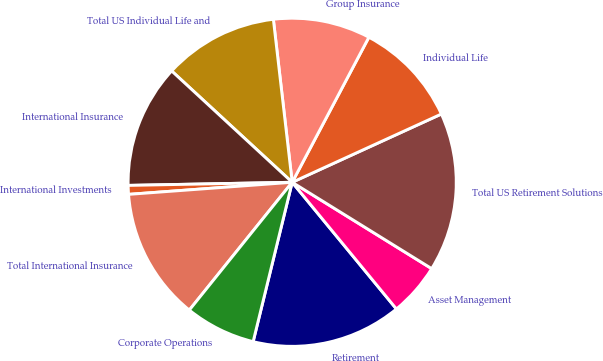<chart> <loc_0><loc_0><loc_500><loc_500><pie_chart><fcel>Retirement<fcel>Asset Management<fcel>Total US Retirement Solutions<fcel>Individual Life<fcel>Group Insurance<fcel>Total US Individual Life and<fcel>International Insurance<fcel>International Investments<fcel>Total International Insurance<fcel>Corporate Operations<nl><fcel>14.78%<fcel>5.22%<fcel>15.65%<fcel>10.43%<fcel>9.57%<fcel>11.3%<fcel>12.17%<fcel>0.87%<fcel>13.04%<fcel>6.96%<nl></chart> 